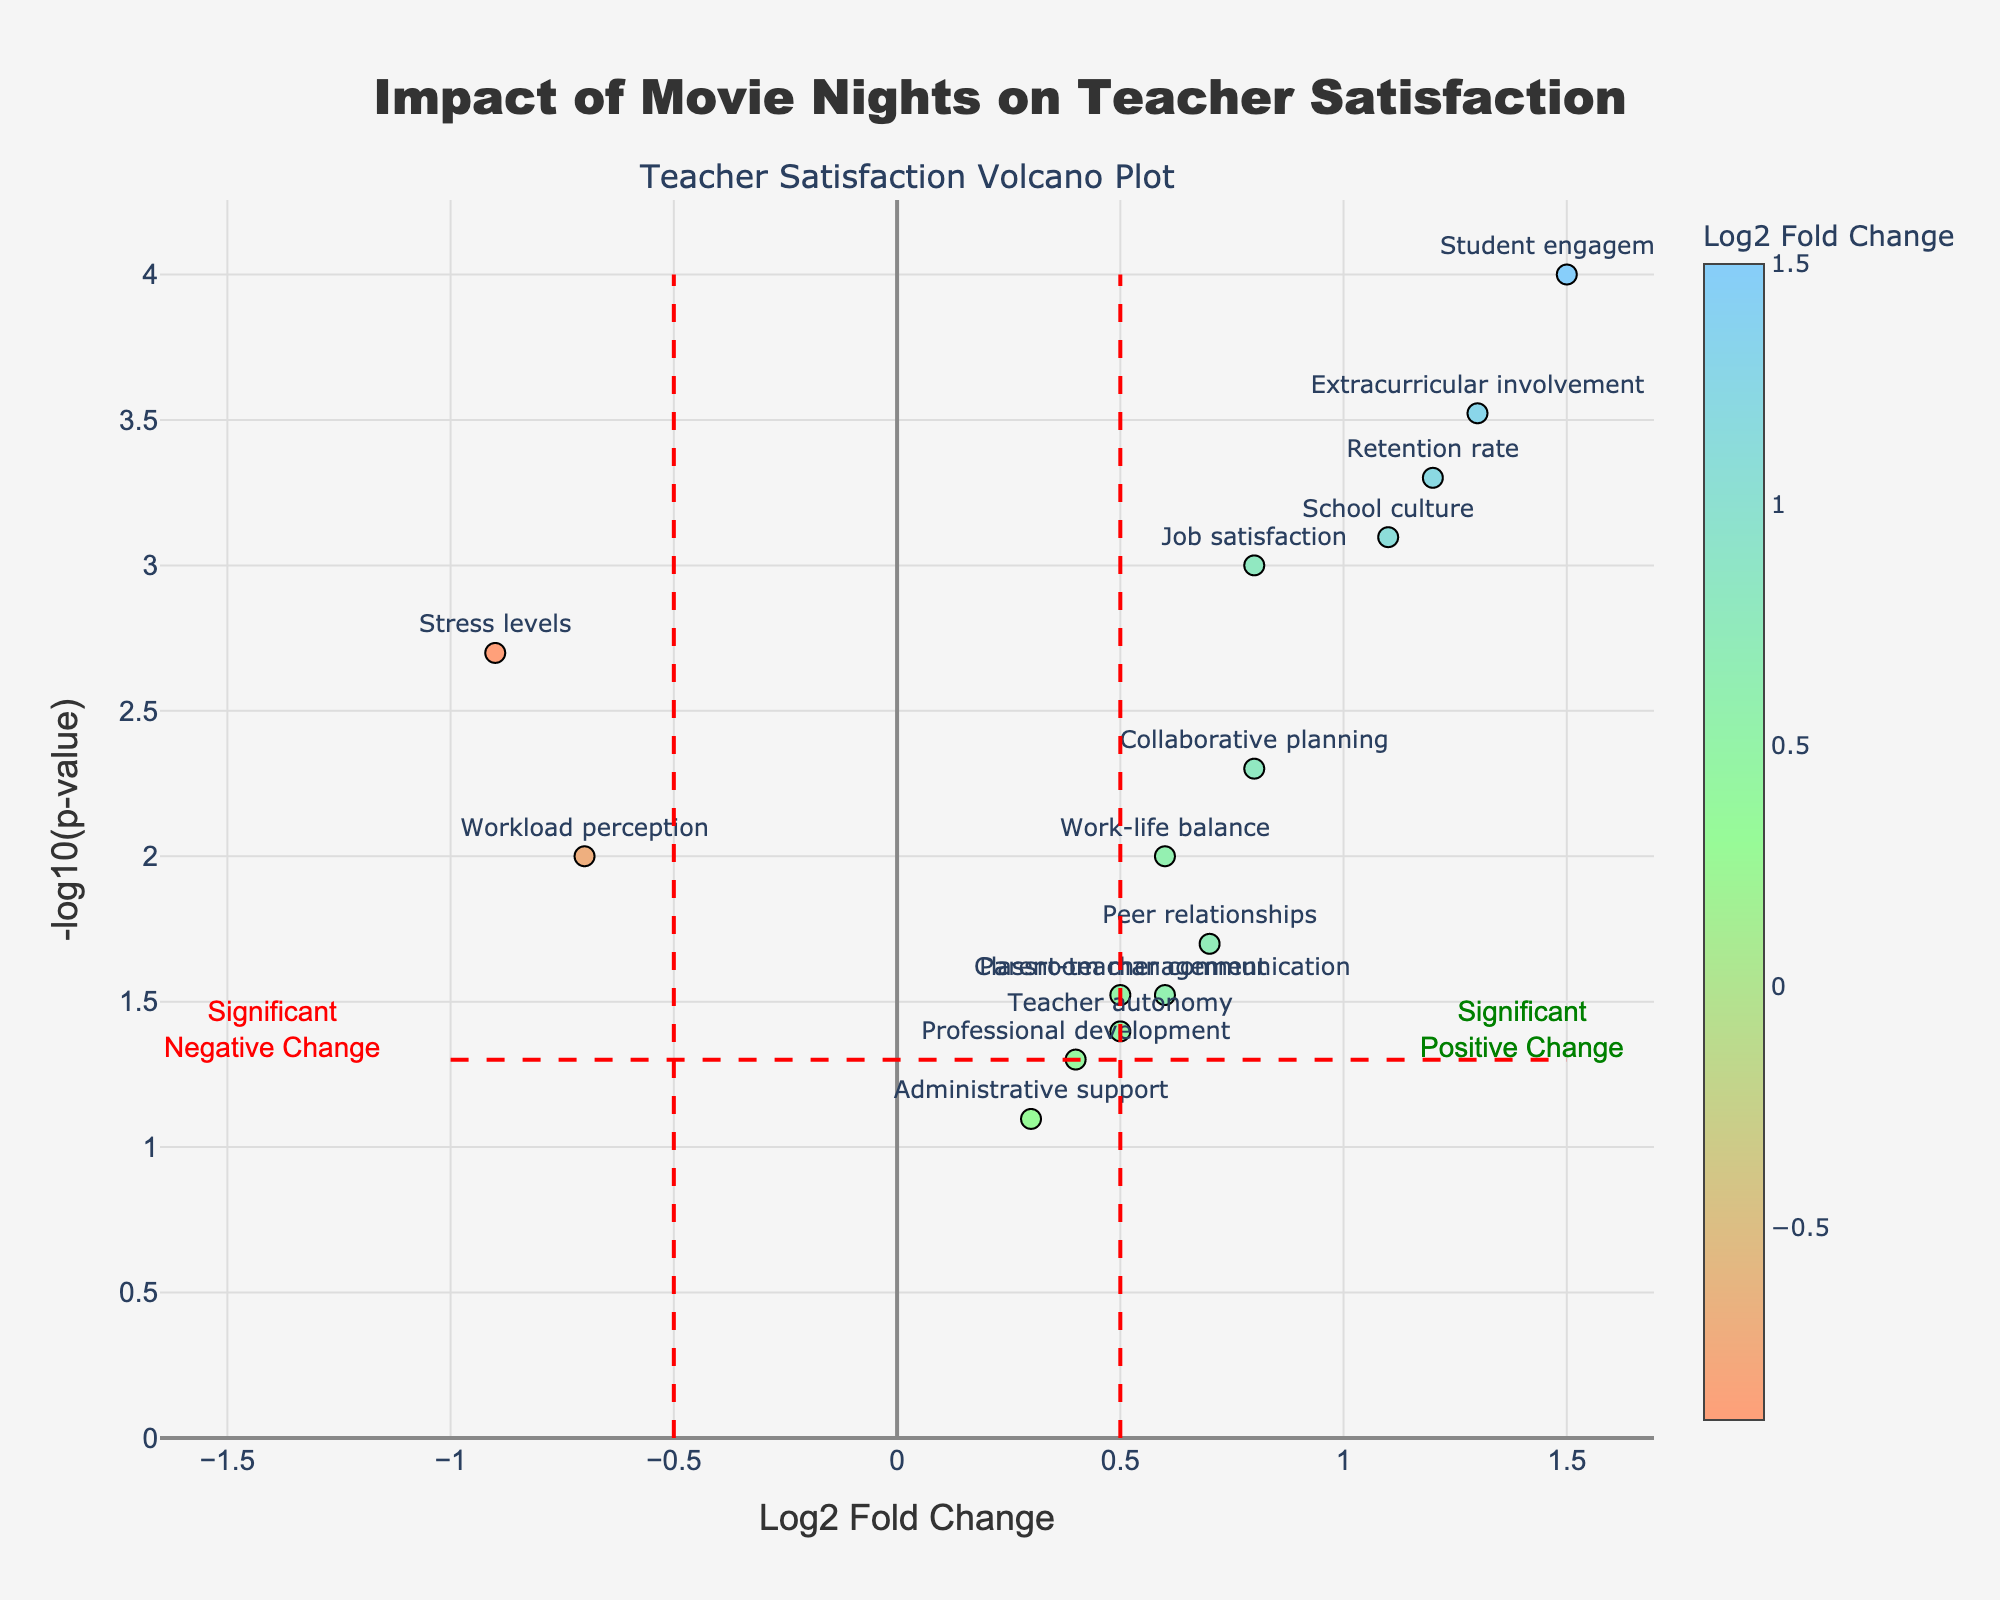Which gene shows the highest positive Log2 Fold Change? The gene with the highest Log2 Fold Change can be identified by the data point furthest to the right on the x-axis. This is the 'Student engagement' data point.
Answer: Student engagement What does a point with a high Log2 Fold Change and a low p-value represent? A high Log2 Fold Change indicates a large change in the variable of interest between pre- and post-movie night periods, while a low p-value (high -log10(p-value)) suggests that this change is statistically significant. Thus, such a point represents a significant and substantial change between the periods.
Answer: Significant and substantial change How many genes show a statistically significant positive change in the post-movie night period? Points to the right of the red vertical line at 0.5 Log2 Fold Change and above the red horizontal line at -log10(p-value) of 1.3 are significant with positive change. These genes are: 'Job satisfaction', 'Retention rate', 'Student engagement', 'Collaborative planning', 'School culture', and 'Extracurricular involvement'.
Answer: 6 Which gene has the highest -log10(p-value)? The gene with the highest -log10(p-value) is the one with the highest position on the y-axis. This is the 'Student engagement' data point.
Answer: Student engagement How does 'Stress levels' compare with 'Retention rate' in terms of Log2 Fold Change? 'Stress levels' has a negative Log2 Fold Change of -0.9 (left of origin), indicating it decreased. 'Retention rate' has a positive Log2 Fold Change of 1.2 (right of origin), indicating it increased.
Answer: 'Stress levels' decreased while 'Retention rate' increased Which quadrant on the plot represents significant negative changes? The quadrant with significant negative changes is the region to the left of the red vertical line at -0.5 Log2 Fold Change and above the red horizontal line at -log10(p-value) of 1.3.
Answer: Top left quadrant Why might 'Administrative support' be considered not significantly changed? 'Administrative support' is below the red horizontal threshold line at -log10(p-value) of 1.3, indicating its p-value (0.08) isn't statistically significant despite its Log2 Fold Change (0.3).
Answer: Not significant based on p-value Is there any gene with a negative change that is statistically significant? Points left of the origin with a high -log10(p-value) are significant. 'Stress levels' and 'Workload perception', to the left of the origin and above the red horizontal line at -log10(p-value) of 1.3, show significant negative changes.
Answer: Yes, 2 genes Which gene shows the smallest change in Log2 Fold Change? The smallest change in Log2 Fold Change happens at the data point closest to the origin on the Log2 Fold Change axis, which for this dataset is 'Administrative support' with a Log2 Fold Change of 0.3.
Answer: Administrative support 